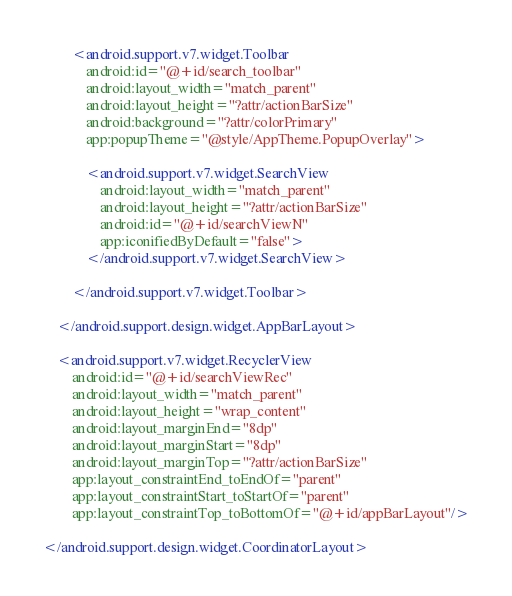Convert code to text. <code><loc_0><loc_0><loc_500><loc_500><_XML_>        <android.support.v7.widget.Toolbar
            android:id="@+id/search_toolbar"
            android:layout_width="match_parent"
            android:layout_height="?attr/actionBarSize"
            android:background="?attr/colorPrimary"
            app:popupTheme="@style/AppTheme.PopupOverlay">

            <android.support.v7.widget.SearchView
                android:layout_width="match_parent"
                android:layout_height="?attr/actionBarSize"
                android:id="@+id/searchViewN"
                app:iconifiedByDefault="false">
            </android.support.v7.widget.SearchView>

        </android.support.v7.widget.Toolbar>

    </android.support.design.widget.AppBarLayout>

    <android.support.v7.widget.RecyclerView
        android:id="@+id/searchViewRec"
        android:layout_width="match_parent"
        android:layout_height="wrap_content"
        android:layout_marginEnd="8dp"
        android:layout_marginStart="8dp"
        android:layout_marginTop="?attr/actionBarSize"
        app:layout_constraintEnd_toEndOf="parent"
        app:layout_constraintStart_toStartOf="parent"
        app:layout_constraintTop_toBottomOf="@+id/appBarLayout"/>

</android.support.design.widget.CoordinatorLayout>
</code> 